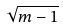<formula> <loc_0><loc_0><loc_500><loc_500>\sqrt { m - 1 }</formula> 